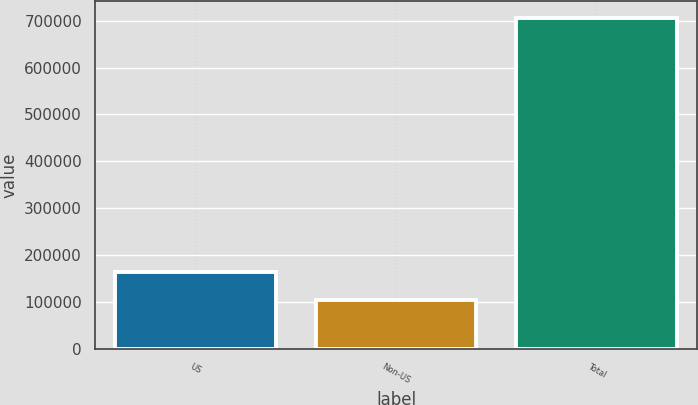Convert chart to OTSL. <chart><loc_0><loc_0><loc_500><loc_500><bar_chart><fcel>US<fcel>Non-US<fcel>Total<nl><fcel>164063<fcel>103774<fcel>706668<nl></chart> 